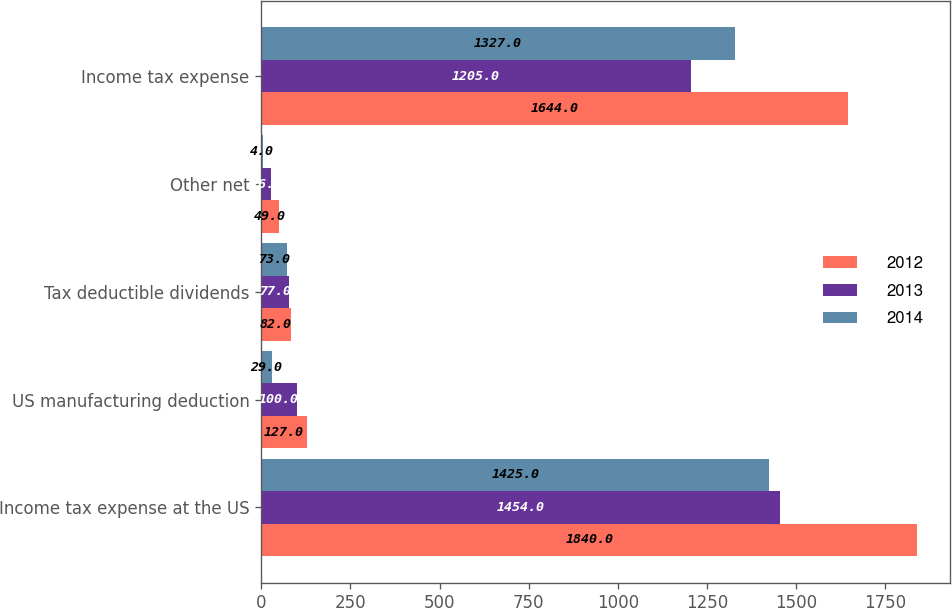Convert chart. <chart><loc_0><loc_0><loc_500><loc_500><stacked_bar_chart><ecel><fcel>Income tax expense at the US<fcel>US manufacturing deduction<fcel>Tax deductible dividends<fcel>Other net<fcel>Income tax expense<nl><fcel>2012<fcel>1840<fcel>127<fcel>82<fcel>49<fcel>1644<nl><fcel>2013<fcel>1454<fcel>100<fcel>77<fcel>26<fcel>1205<nl><fcel>2014<fcel>1425<fcel>29<fcel>73<fcel>4<fcel>1327<nl></chart> 